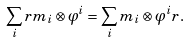Convert formula to latex. <formula><loc_0><loc_0><loc_500><loc_500>\sum _ { i } r m _ { i } \otimes \varphi ^ { i } = \sum _ { i } m _ { i } \otimes \varphi ^ { i } r .</formula> 